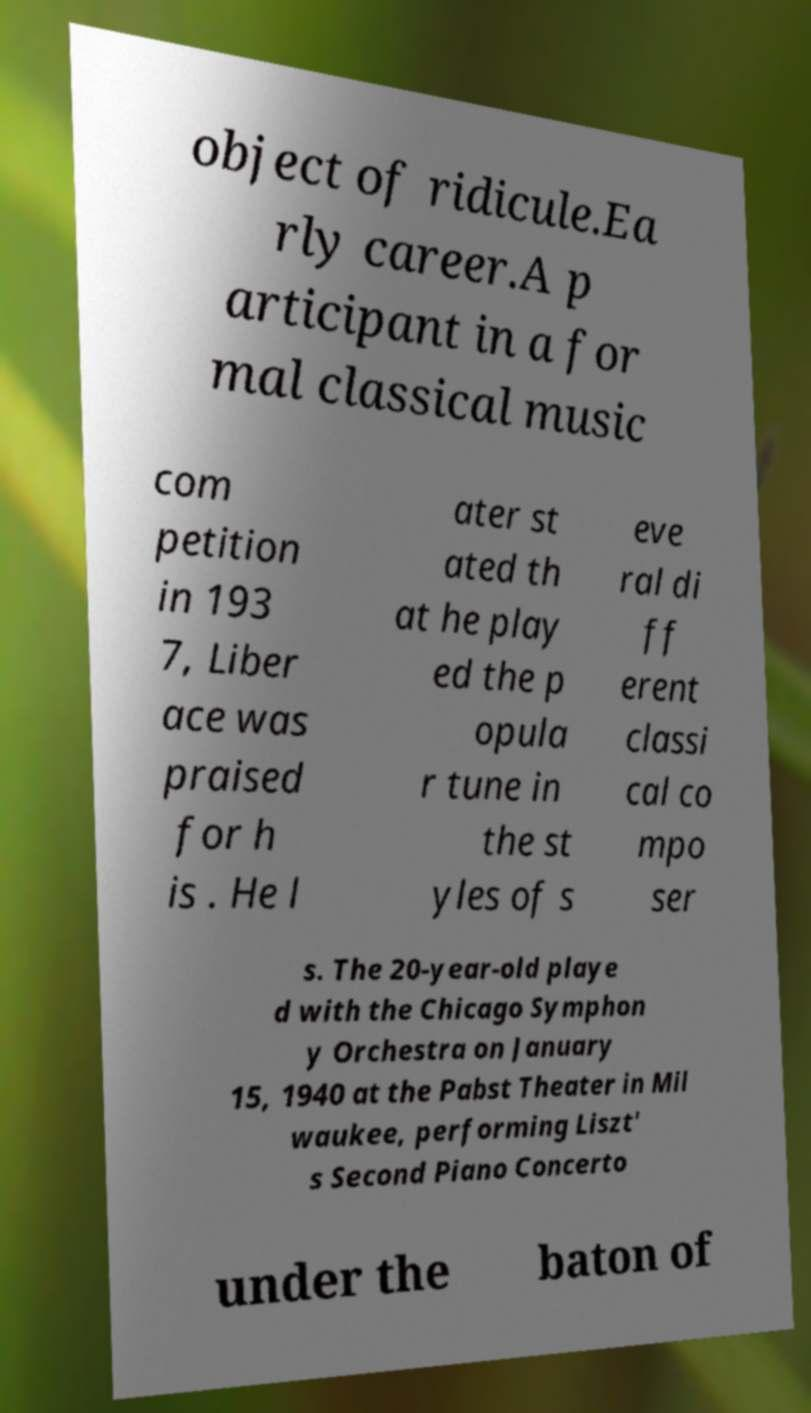Can you accurately transcribe the text from the provided image for me? object of ridicule.Ea rly career.A p articipant in a for mal classical music com petition in 193 7, Liber ace was praised for h is . He l ater st ated th at he play ed the p opula r tune in the st yles of s eve ral di ff erent classi cal co mpo ser s. The 20-year-old playe d with the Chicago Symphon y Orchestra on January 15, 1940 at the Pabst Theater in Mil waukee, performing Liszt' s Second Piano Concerto under the baton of 